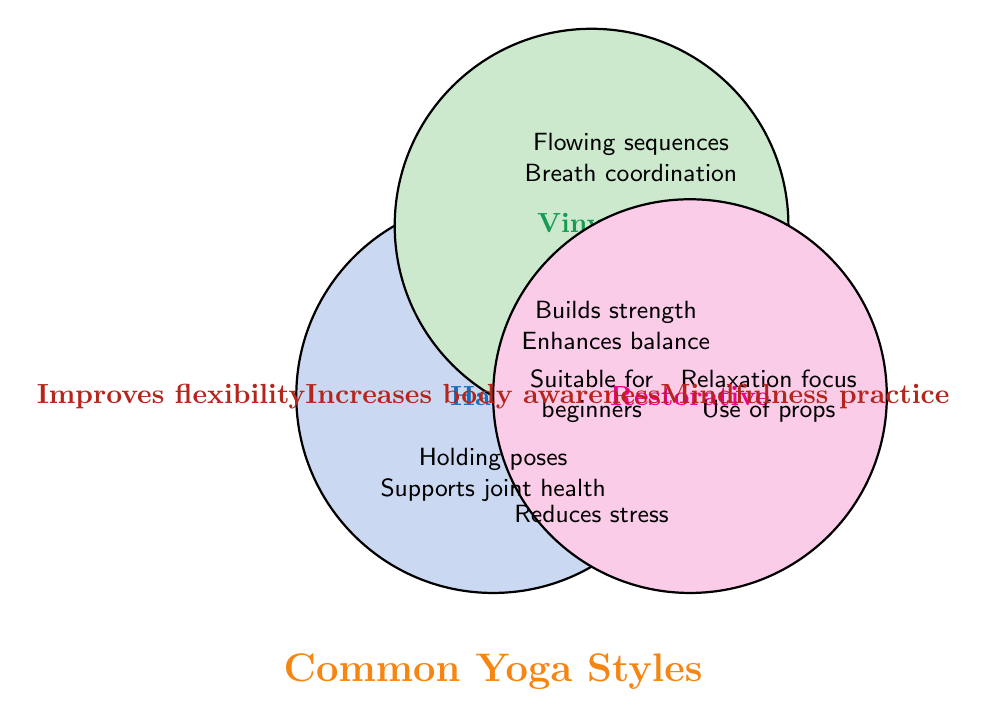What are the common characteristics among all the listed yoga styles? The area where all three circles intersect represents common traits. This area includes "Improves flexibility," "Increases body awareness," and "Mindfulness practice."
Answer: Improves flexibility, Increases body awareness, Mindfulness practice Which yoga style focuses on relaxation and the use of props? Both "Relaxation focus" and "Use of props" are listed under Restorative yoga, as indicated by their placement within the Restorative circle.
Answer: Restorative What unique benefits does Hatha yoga offer compared to Vinyasa? Unique benefits for Hatha yoga not shared with Vinyasa are "Holding poses" and "Supports joint health," as these are exclusive to Hatha and not found in the Vinyasa circle.
Answer: Holding poses, Supports joint health Between Hatha and Restorative yoga, which style also builds strength? Hatha and Vinyasa both build strength as the "Builds strength" trait is found in the overlapping area of their circles, but Restorative does not build strength as it is not represented in the overlapping sections.
Answer: Hatha What benefit is shared by Hatha and Vinyasa but not by Restorative? The overlapping region between Hatha and Vinyasa indicates shared benefits, which are "Builds strength" and "Enhances balance." Restorative does not share these traits.
Answer: Builds strength, Enhances balance Which yoga style is identified as suitable for beginners? The trait "Suitable for beginners" is found in both Hatha and Restorative yoga, as indicated by its position within these two individual sections of the circles.
Answer: Hatha, Restorative What trait is exclusive to Vinyasa yoga? "Flowing sequences," "Breath coordination," and "Energy boost" are all traits found only within the Vinyasa circle and therefore are unique to it.
Answer: Flowing sequences, Breath coordination, Energy boost How many benefits are exclusive to the Restorative yoga style? The exclusive traits of Restorative yoga listed within its circle and not shared with the others are "Relaxation focus," "Use of props," and "Reduces stress." There are three such benefits.
Answer: Three Which yoga styles incorporate mindfulness practice? The "Mindfulness practice" trait is located at the intersection of all three circles, indicating that it is a common trait among Hatha, Vinyasa, and Restorative yoga styles.
Answer: Hatha, Vinyasa, Restorative 